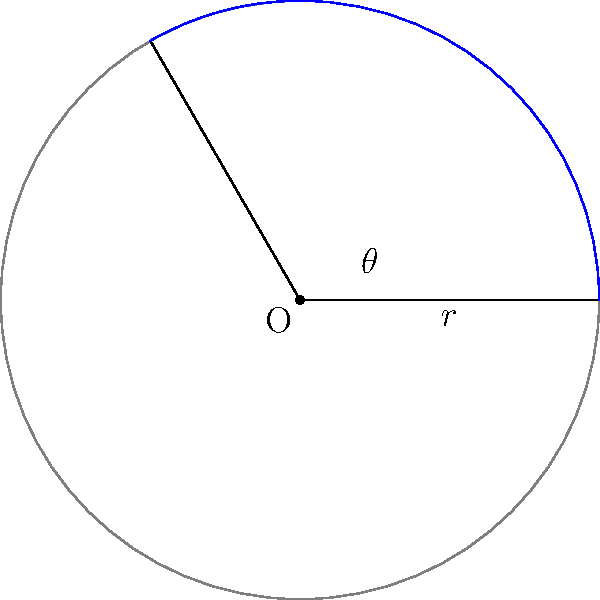As a data analyst working with an experimental physicist, you need to calculate the area of a circular sector. Given a circle with radius $r = 5$ cm and a central angle $\theta = 120°$, determine the area of the blue sector. Round your answer to two decimal places. To calculate the area of a circular sector, we can follow these steps:

1) The formula for the area of a circular sector is:

   $$A = \frac{1}{2} r^2 \theta$$

   Where $A$ is the area, $r$ is the radius, and $\theta$ is the central angle in radians.

2) We're given $r = 5$ cm and $\theta = 120°$. However, we need to convert the angle to radians:

   $$\theta \text{ (in radians)} = 120° \times \frac{\pi}{180°} = \frac{2\pi}{3} \approx 2.0944$$

3) Now we can substitute these values into our formula:

   $$A = \frac{1}{2} (5\text{ cm})^2 \times \frac{2\pi}{3}$$

4) Let's calculate:

   $$A = \frac{1}{2} \times 25\text{ cm}^2 \times \frac{2\pi}{3}$$
   $$A = \frac{25\pi}{3}\text{ cm}^2$$

5) Evaluating this and rounding to two decimal places:

   $$A \approx 26.18\text{ cm}^2$$

Thus, the area of the circular sector is approximately 26.18 cm².
Answer: 26.18 cm² 